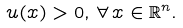Convert formula to latex. <formula><loc_0><loc_0><loc_500><loc_500>u ( x ) > 0 , \, \forall \, x \in \mathbb { R } ^ { n } .</formula> 